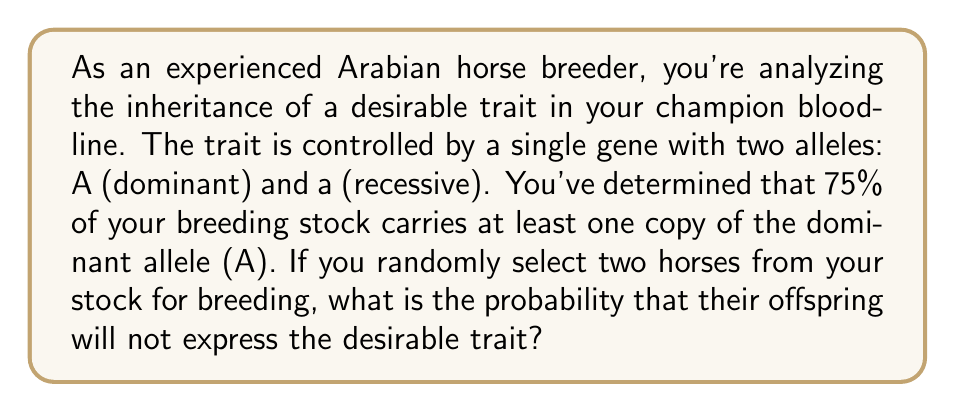Help me with this question. Let's approach this step-by-step:

1) First, we need to understand what it means for an offspring to not express the trait. This will only happen if the offspring inherits two recessive alleles (aa).

2) We're told that 75% of the breeding stock carries at least one dominant allele (A). This means that 25% of the stock must be homozygous recessive (aa).

3) For a horse to pass on the recessive allele, it must either be:
   - Homozygous recessive (aa) - probability 0.25
   - Heterozygous (Aa) and pass on the recessive allele - probability 0.75 * 0.5 = 0.375

4) The total probability of a horse passing on the recessive allele is:
   $$ P(a) = 0.25 + 0.375 = 0.625 $$

5) For the offspring to be aa, both parents must pass on the recessive allele. The probability of this is:
   $$ P(aa) = P(a) \times P(a) = 0.625 \times 0.625 = 0.390625 $$

6) Therefore, the probability that the offspring will not express the desirable trait is 0.390625 or about 39.06%.
Answer: The probability that the offspring will not express the desirable trait is $0.390625$ or approximately $39.06\%$. 